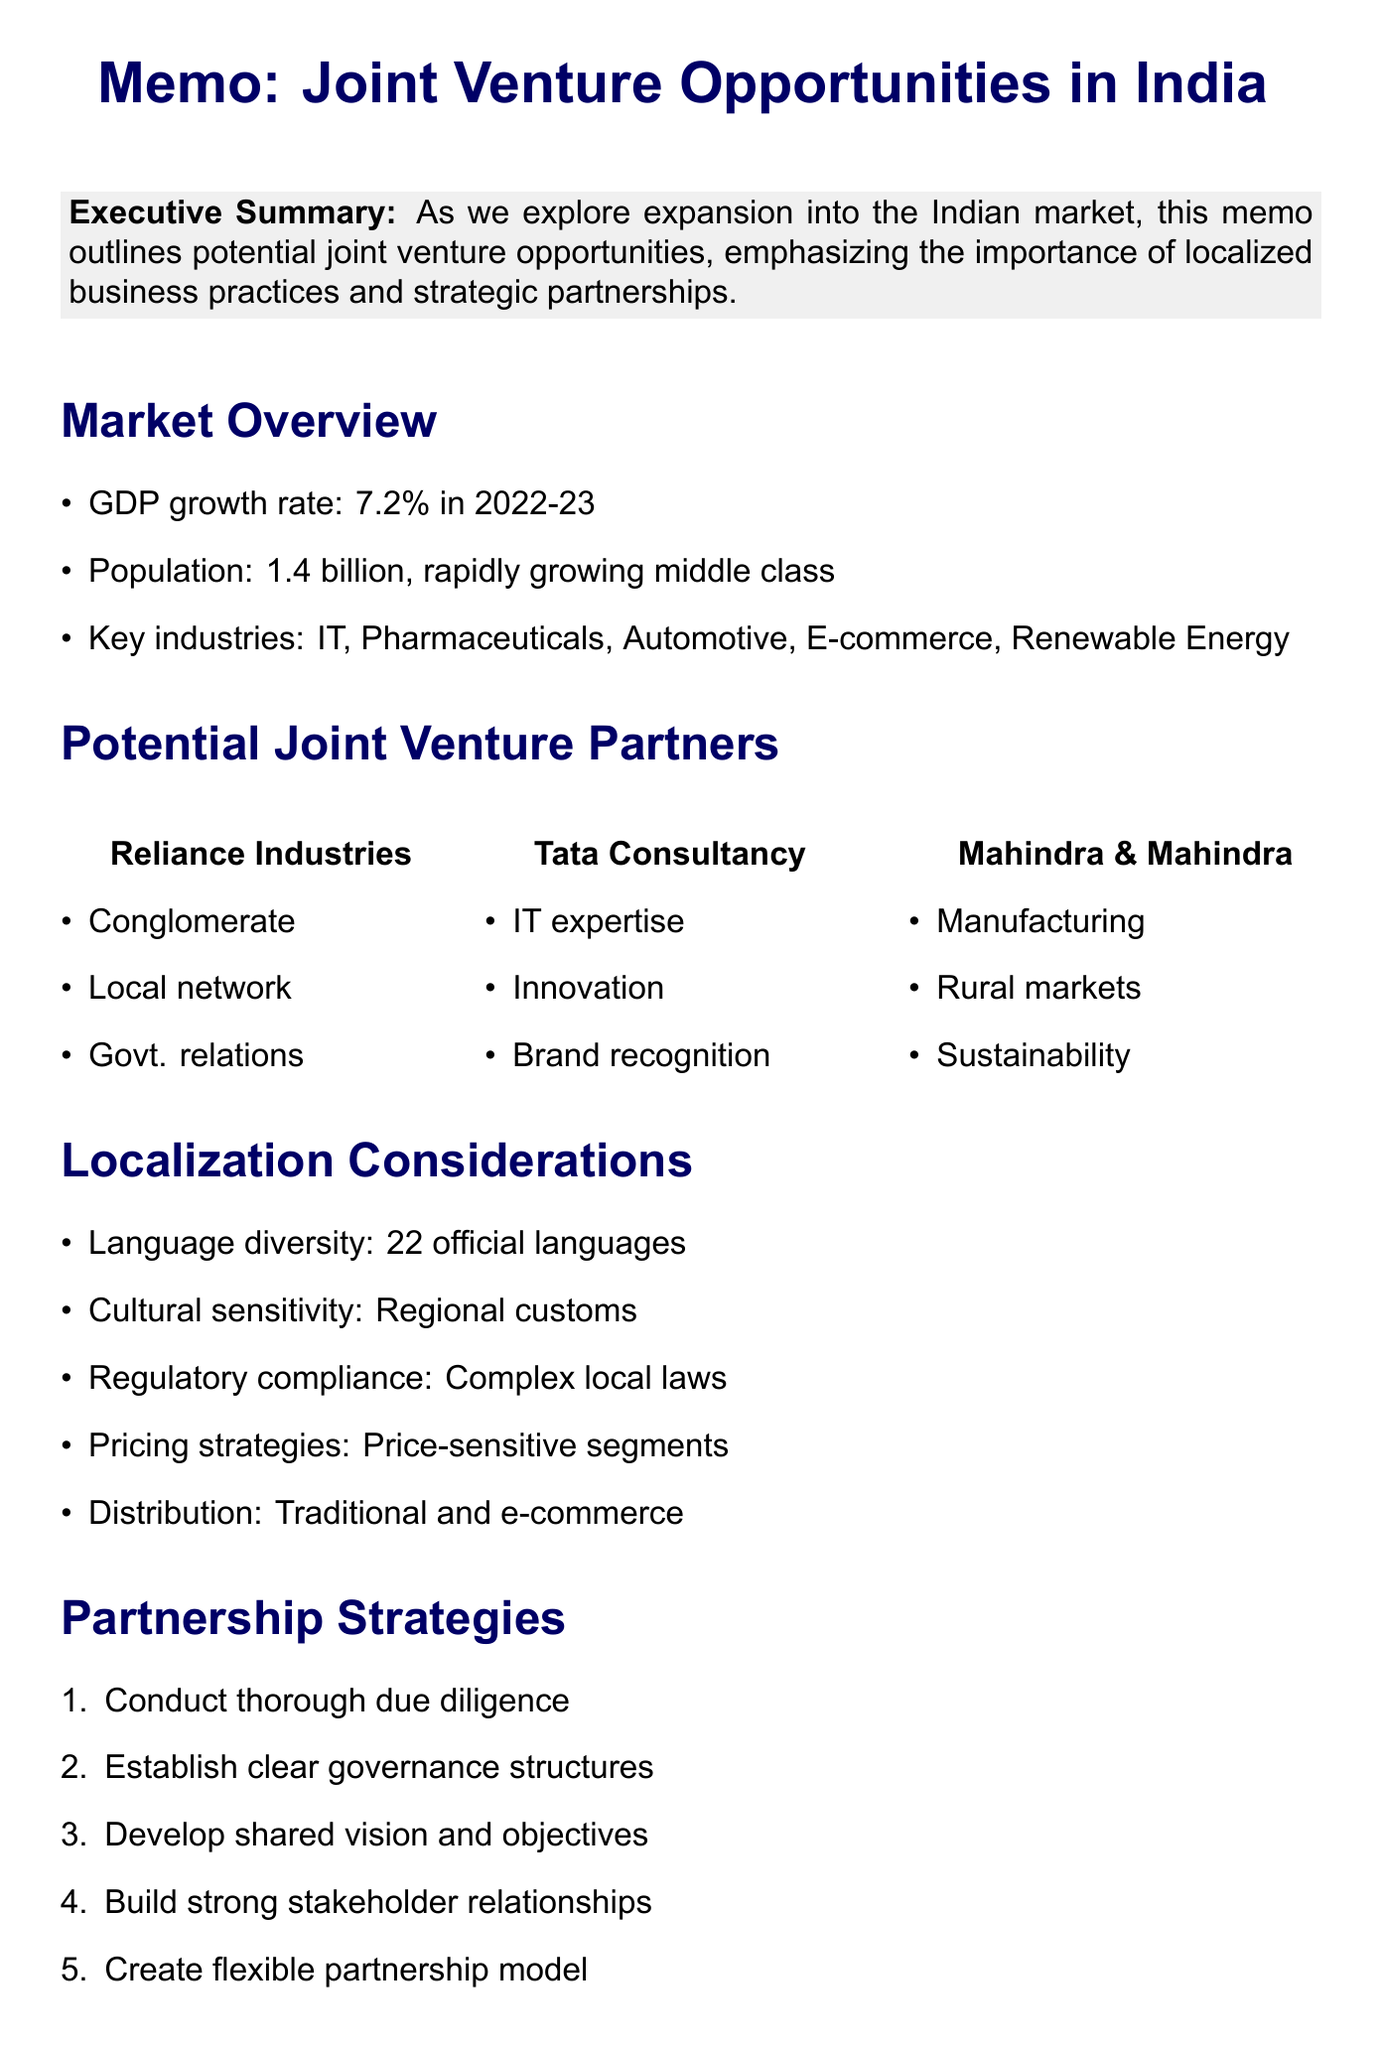what is the GDP growth rate for India in 2022-23? The document states that India's GDP growth rate is 7.2% for the year 2022-23.
Answer: 7.2% how many official languages are there in India? The memo mentions that there are 22 official languages in India.
Answer: 22 which company is noted for its global IT expertise? The document highlights Tata Consultancy Services as having global IT expertise.
Answer: Tata Consultancy Services what is a key industry mentioned for potential joint ventures? The memo lists various key industries, including Information Technology.
Answer: Information Technology what is one consideration for localization mentioned? The document outlines several localization considerations, one of which is cultural sensitivity.
Answer: Cultural sensitivity what are two strengths that Reliance Industries offers for partnership? The document states that Reliance Industries has an extensive local network and strong government relations.
Answer: Extensive local network, strong government relations what risk is associated with regulatory changes? The memo identifies regulatory changes as a risk and recommends engaging local legal experts as mitigation.
Answer: Regulatory changes what is one next step recommended in the document? The memo recommends engaging the localization specialist to conduct in-depth market research as one of the next steps.
Answer: Engage our localization specialist what is the main conclusion of the memo? The conclusion states that the Indian market presents significant opportunities for expansion plans.
Answer: Significant opportunities for expansion plans 